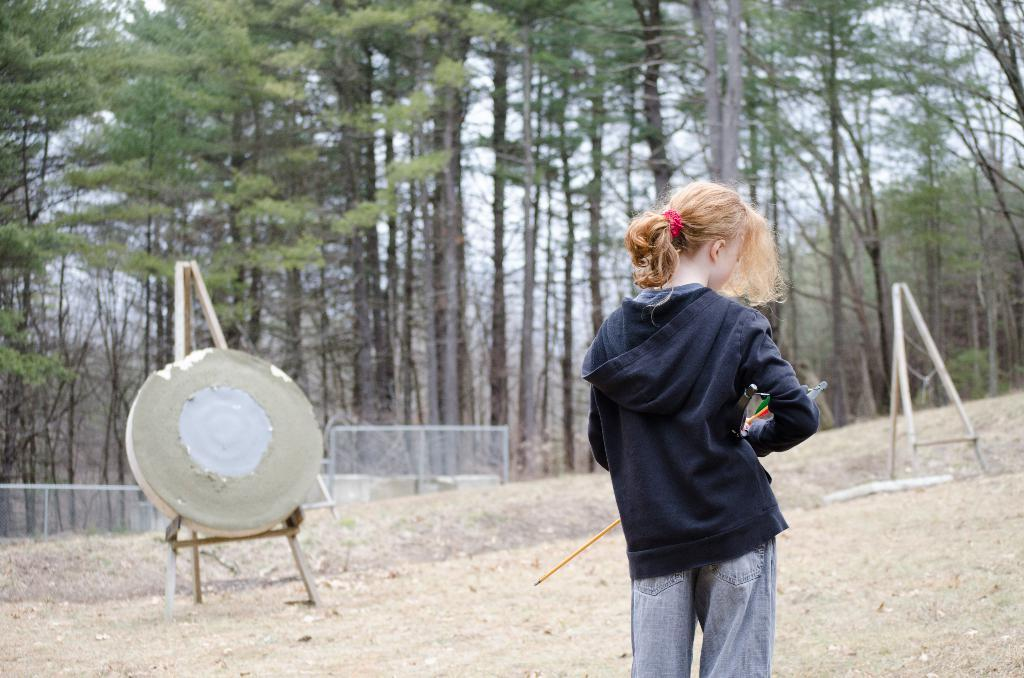Who is present in the image? There is a woman in the image. What is the woman wearing? The woman is wearing a black hoodie. What is the woman holding in the image? The woman is holding an object called "archer." What can be seen in the background of the image? There are trees and a fence in the background of the image. What might the woman be using the "archer" object for? The woman might be using the "archer" object for target practice, as there is a target board in the image. What type of print can be seen on the tray in the image? There is no tray present in the image, and therefore no print can be observed. 